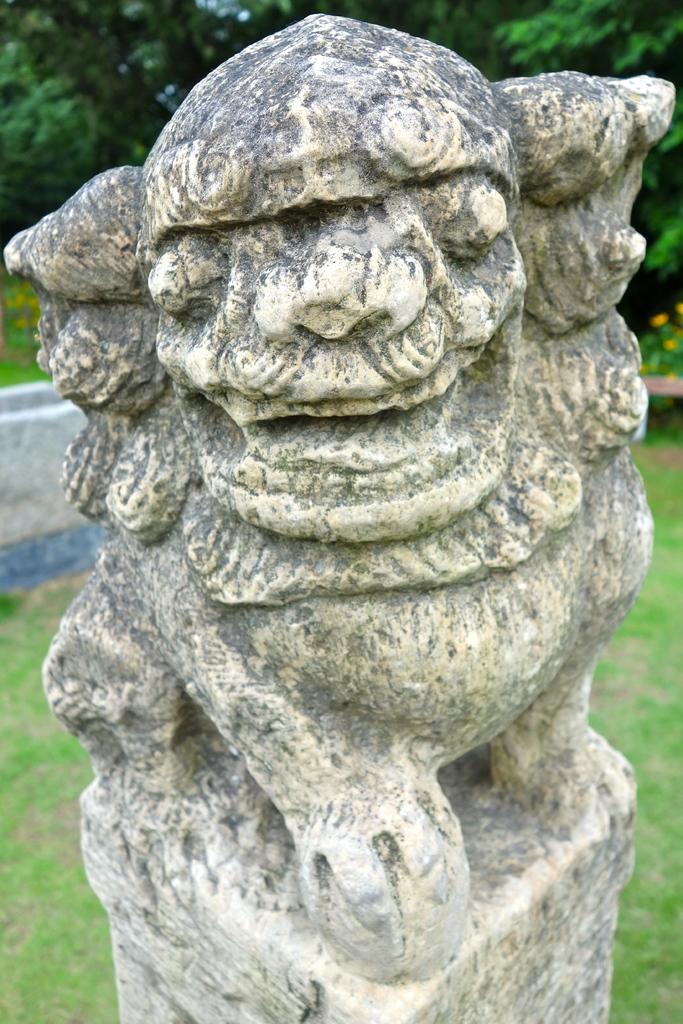Please provide a concise description of this image. In this image I can see a statue in cream color, background I can see few flowers in yellow color, grass and trees in green color and the sky is in white color. 